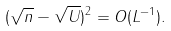Convert formula to latex. <formula><loc_0><loc_0><loc_500><loc_500>( \sqrt { n } - \sqrt { U } ) ^ { 2 } = O ( L ^ { - 1 } ) .</formula> 